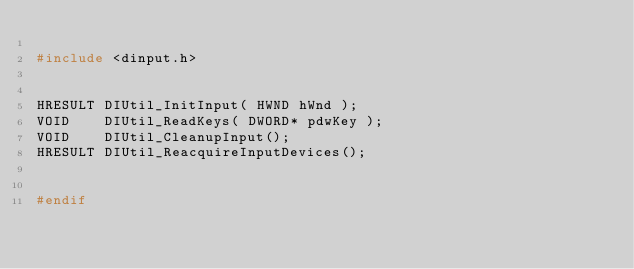<code> <loc_0><loc_0><loc_500><loc_500><_C_>
#include <dinput.h>


HRESULT DIUtil_InitInput( HWND hWnd );
VOID    DIUtil_ReadKeys( DWORD* pdwKey );
VOID    DIUtil_CleanupInput();
HRESULT DIUtil_ReacquireInputDevices();


#endif



</code> 